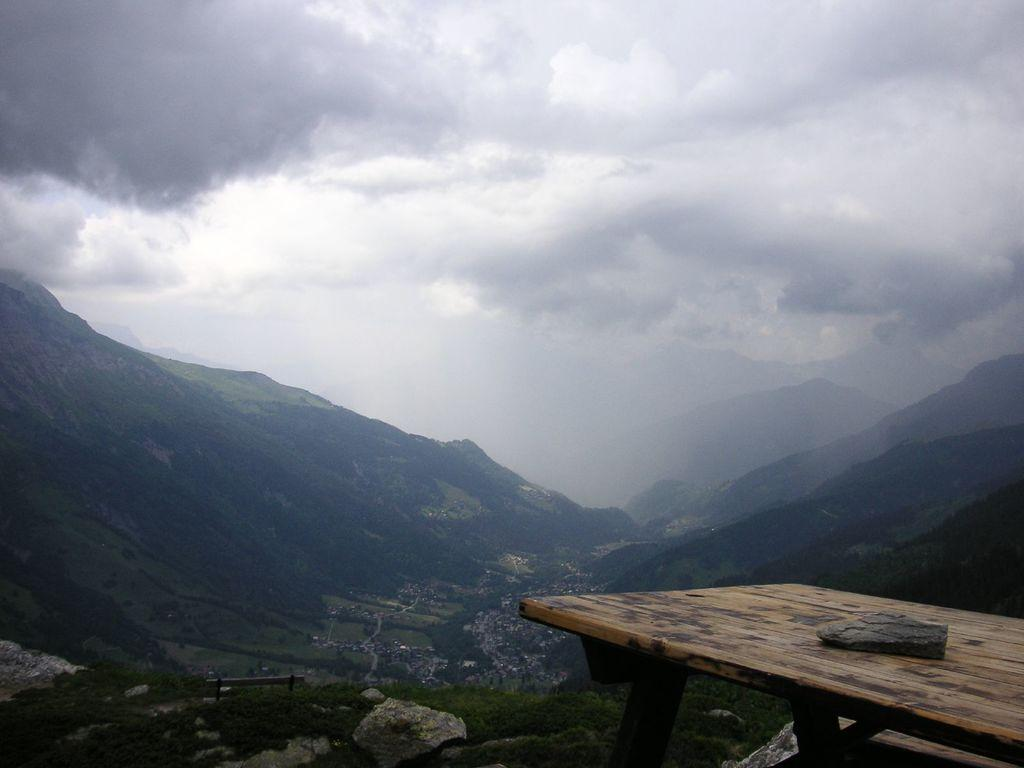What is the main object in the image? There is a table in the image. Where is the table located? The table is on a mountain. What can be seen in the distance behind the table? Multiple mountains are visible in the background of the image. How many members of the family are visible in the image? There is no family present in the image; it only features a table on a mountain with multiple mountains visible in the background. 